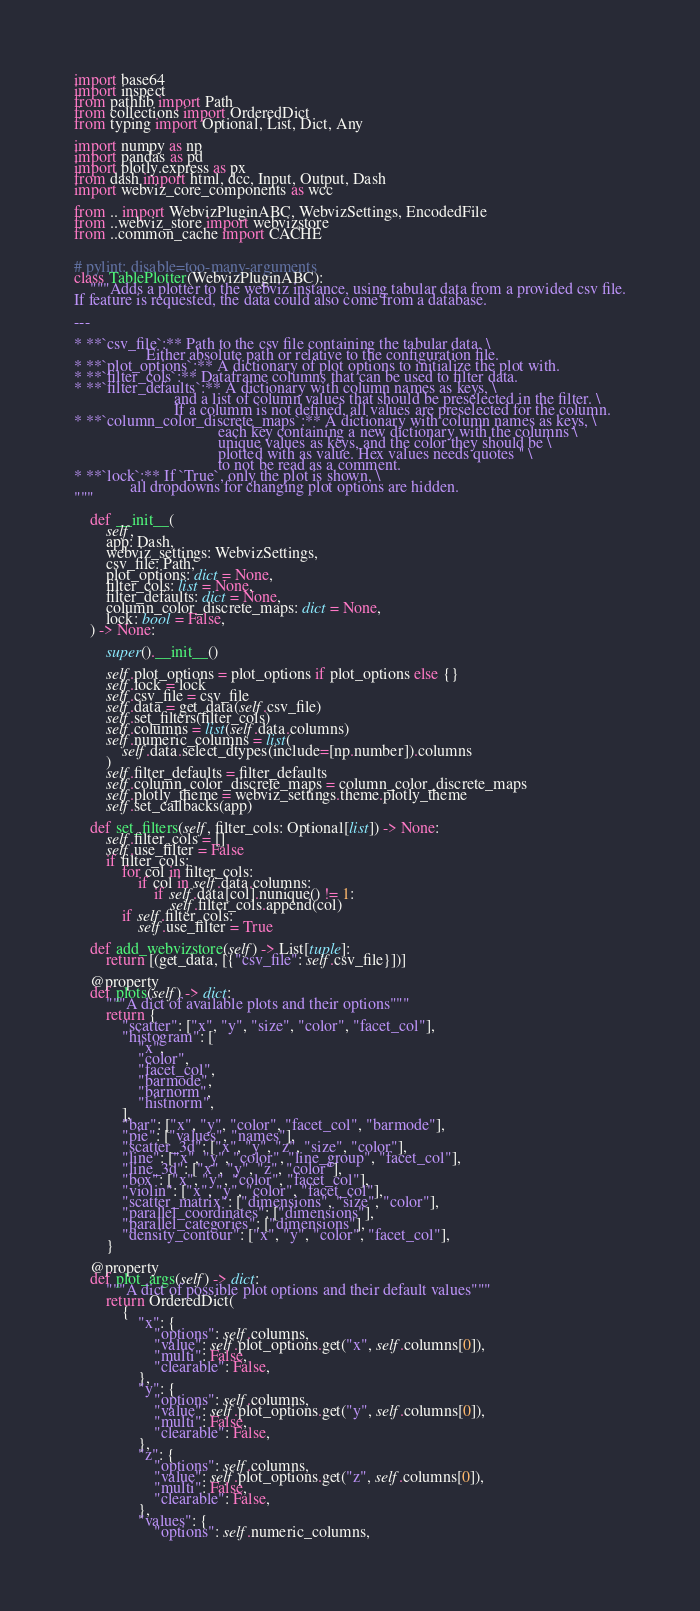<code> <loc_0><loc_0><loc_500><loc_500><_Python_>import base64
import inspect
from pathlib import Path
from collections import OrderedDict
from typing import Optional, List, Dict, Any

import numpy as np
import pandas as pd
import plotly.express as px
from dash import html, dcc, Input, Output, Dash
import webviz_core_components as wcc

from .. import WebvizPluginABC, WebvizSettings, EncodedFile
from ..webviz_store import webvizstore
from ..common_cache import CACHE


# pylint: disable=too-many-arguments
class TablePlotter(WebvizPluginABC):
    """Adds a plotter to the webviz instance, using tabular data from a provided csv file.
If feature is requested, the data could also come from a database.

---

* **`csv_file`:** Path to the csv file containing the tabular data. \
                  Either absolute path or relative to the configuration file.
* **`plot_options`:** A dictionary of plot options to initialize the plot with.
* **`filter_cols`:** Dataframe columns that can be used to filter data.
* **`filter_defaults`:** A dictionary with column names as keys, \
                         and a list of column values that should be preselected in the filter. \
                         If a columm is not defined, all values are preselected for the column.
* **`column_color_discrete_maps`:** A dictionary with column names as keys, \
                                    each key containing a new dictionary with the columns \
                                    unique values as keys, and the color they should be \
                                    plotted with as value. Hex values needs quotes '' \
                                    to not be read as a comment.
* **`lock`:** If `True`, only the plot is shown, \
              all dropdowns for changing plot options are hidden.
"""

    def __init__(
        self,
        app: Dash,
        webviz_settings: WebvizSettings,
        csv_file: Path,
        plot_options: dict = None,
        filter_cols: list = None,
        filter_defaults: dict = None,
        column_color_discrete_maps: dict = None,
        lock: bool = False,
    ) -> None:

        super().__init__()

        self.plot_options = plot_options if plot_options else {}
        self.lock = lock
        self.csv_file = csv_file
        self.data = get_data(self.csv_file)
        self.set_filters(filter_cols)
        self.columns = list(self.data.columns)
        self.numeric_columns = list(
            self.data.select_dtypes(include=[np.number]).columns
        )
        self.filter_defaults = filter_defaults
        self.column_color_discrete_maps = column_color_discrete_maps
        self.plotly_theme = webviz_settings.theme.plotly_theme
        self.set_callbacks(app)

    def set_filters(self, filter_cols: Optional[list]) -> None:
        self.filter_cols = []
        self.use_filter = False
        if filter_cols:
            for col in filter_cols:
                if col in self.data.columns:
                    if self.data[col].nunique() != 1:
                        self.filter_cols.append(col)
            if self.filter_cols:
                self.use_filter = True

    def add_webvizstore(self) -> List[tuple]:
        return [(get_data, [{"csv_file": self.csv_file}])]

    @property
    def plots(self) -> dict:
        """A dict of available plots and their options"""
        return {
            "scatter": ["x", "y", "size", "color", "facet_col"],
            "histogram": [
                "x",
                "color",
                "facet_col",
                "barmode",
                "barnorm",
                "histnorm",
            ],
            "bar": ["x", "y", "color", "facet_col", "barmode"],
            "pie": ["values", "names"],
            "scatter_3d": ["x", "y", "z", "size", "color"],
            "line": ["x", "y", "color", "line_group", "facet_col"],
            "line_3d": ["x", "y", "z", "color"],
            "box": ["x", "y", "color", "facet_col"],
            "violin": ["x", "y", "color", "facet_col"],
            "scatter_matrix": ["dimensions", "size", "color"],
            "parallel_coordinates": ["dimensions"],
            "parallel_categories": ["dimensions"],
            "density_contour": ["x", "y", "color", "facet_col"],
        }

    @property
    def plot_args(self) -> dict:
        """A dict of possible plot options and their default values"""
        return OrderedDict(
            {
                "x": {
                    "options": self.columns,
                    "value": self.plot_options.get("x", self.columns[0]),
                    "multi": False,
                    "clearable": False,
                },
                "y": {
                    "options": self.columns,
                    "value": self.plot_options.get("y", self.columns[0]),
                    "multi": False,
                    "clearable": False,
                },
                "z": {
                    "options": self.columns,
                    "value": self.plot_options.get("z", self.columns[0]),
                    "multi": False,
                    "clearable": False,
                },
                "values": {
                    "options": self.numeric_columns,</code> 